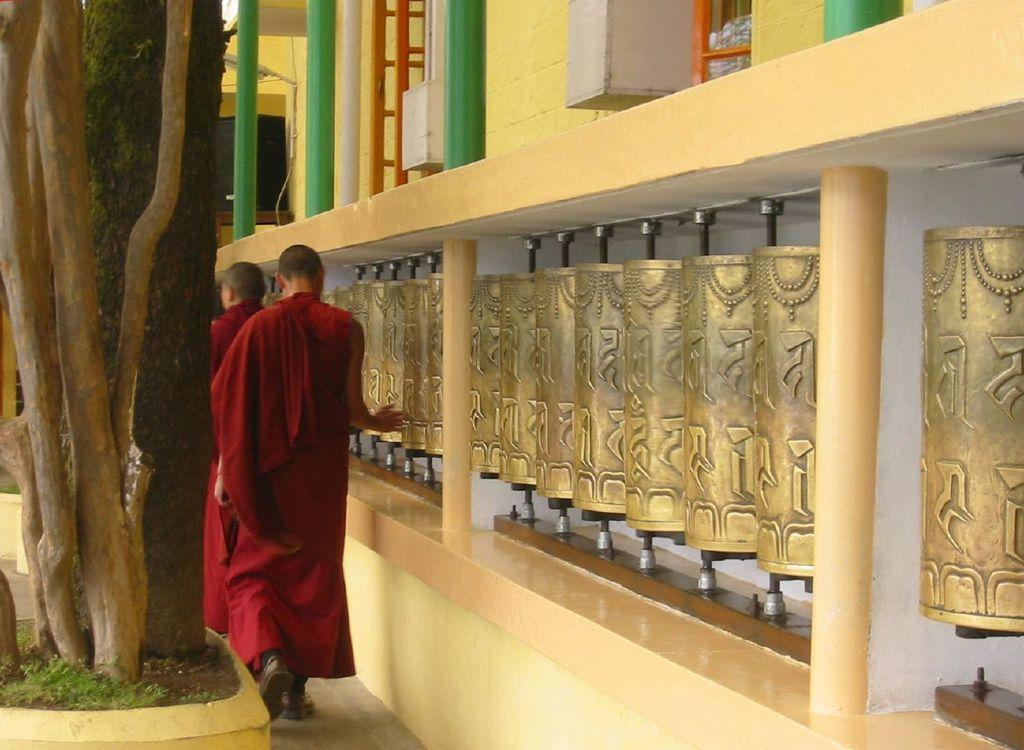What are the two people in the image doing? The two people in the image are walking. What can be seen on the left side of the image? There are trees on the left side of the image. What is located beside the trees? There are objects beside the trees. What is above the objects beside the trees? There is a building above the objects. How many balls are being juggled by the people in the image? There are no balls present in the image; the two people are walking. 